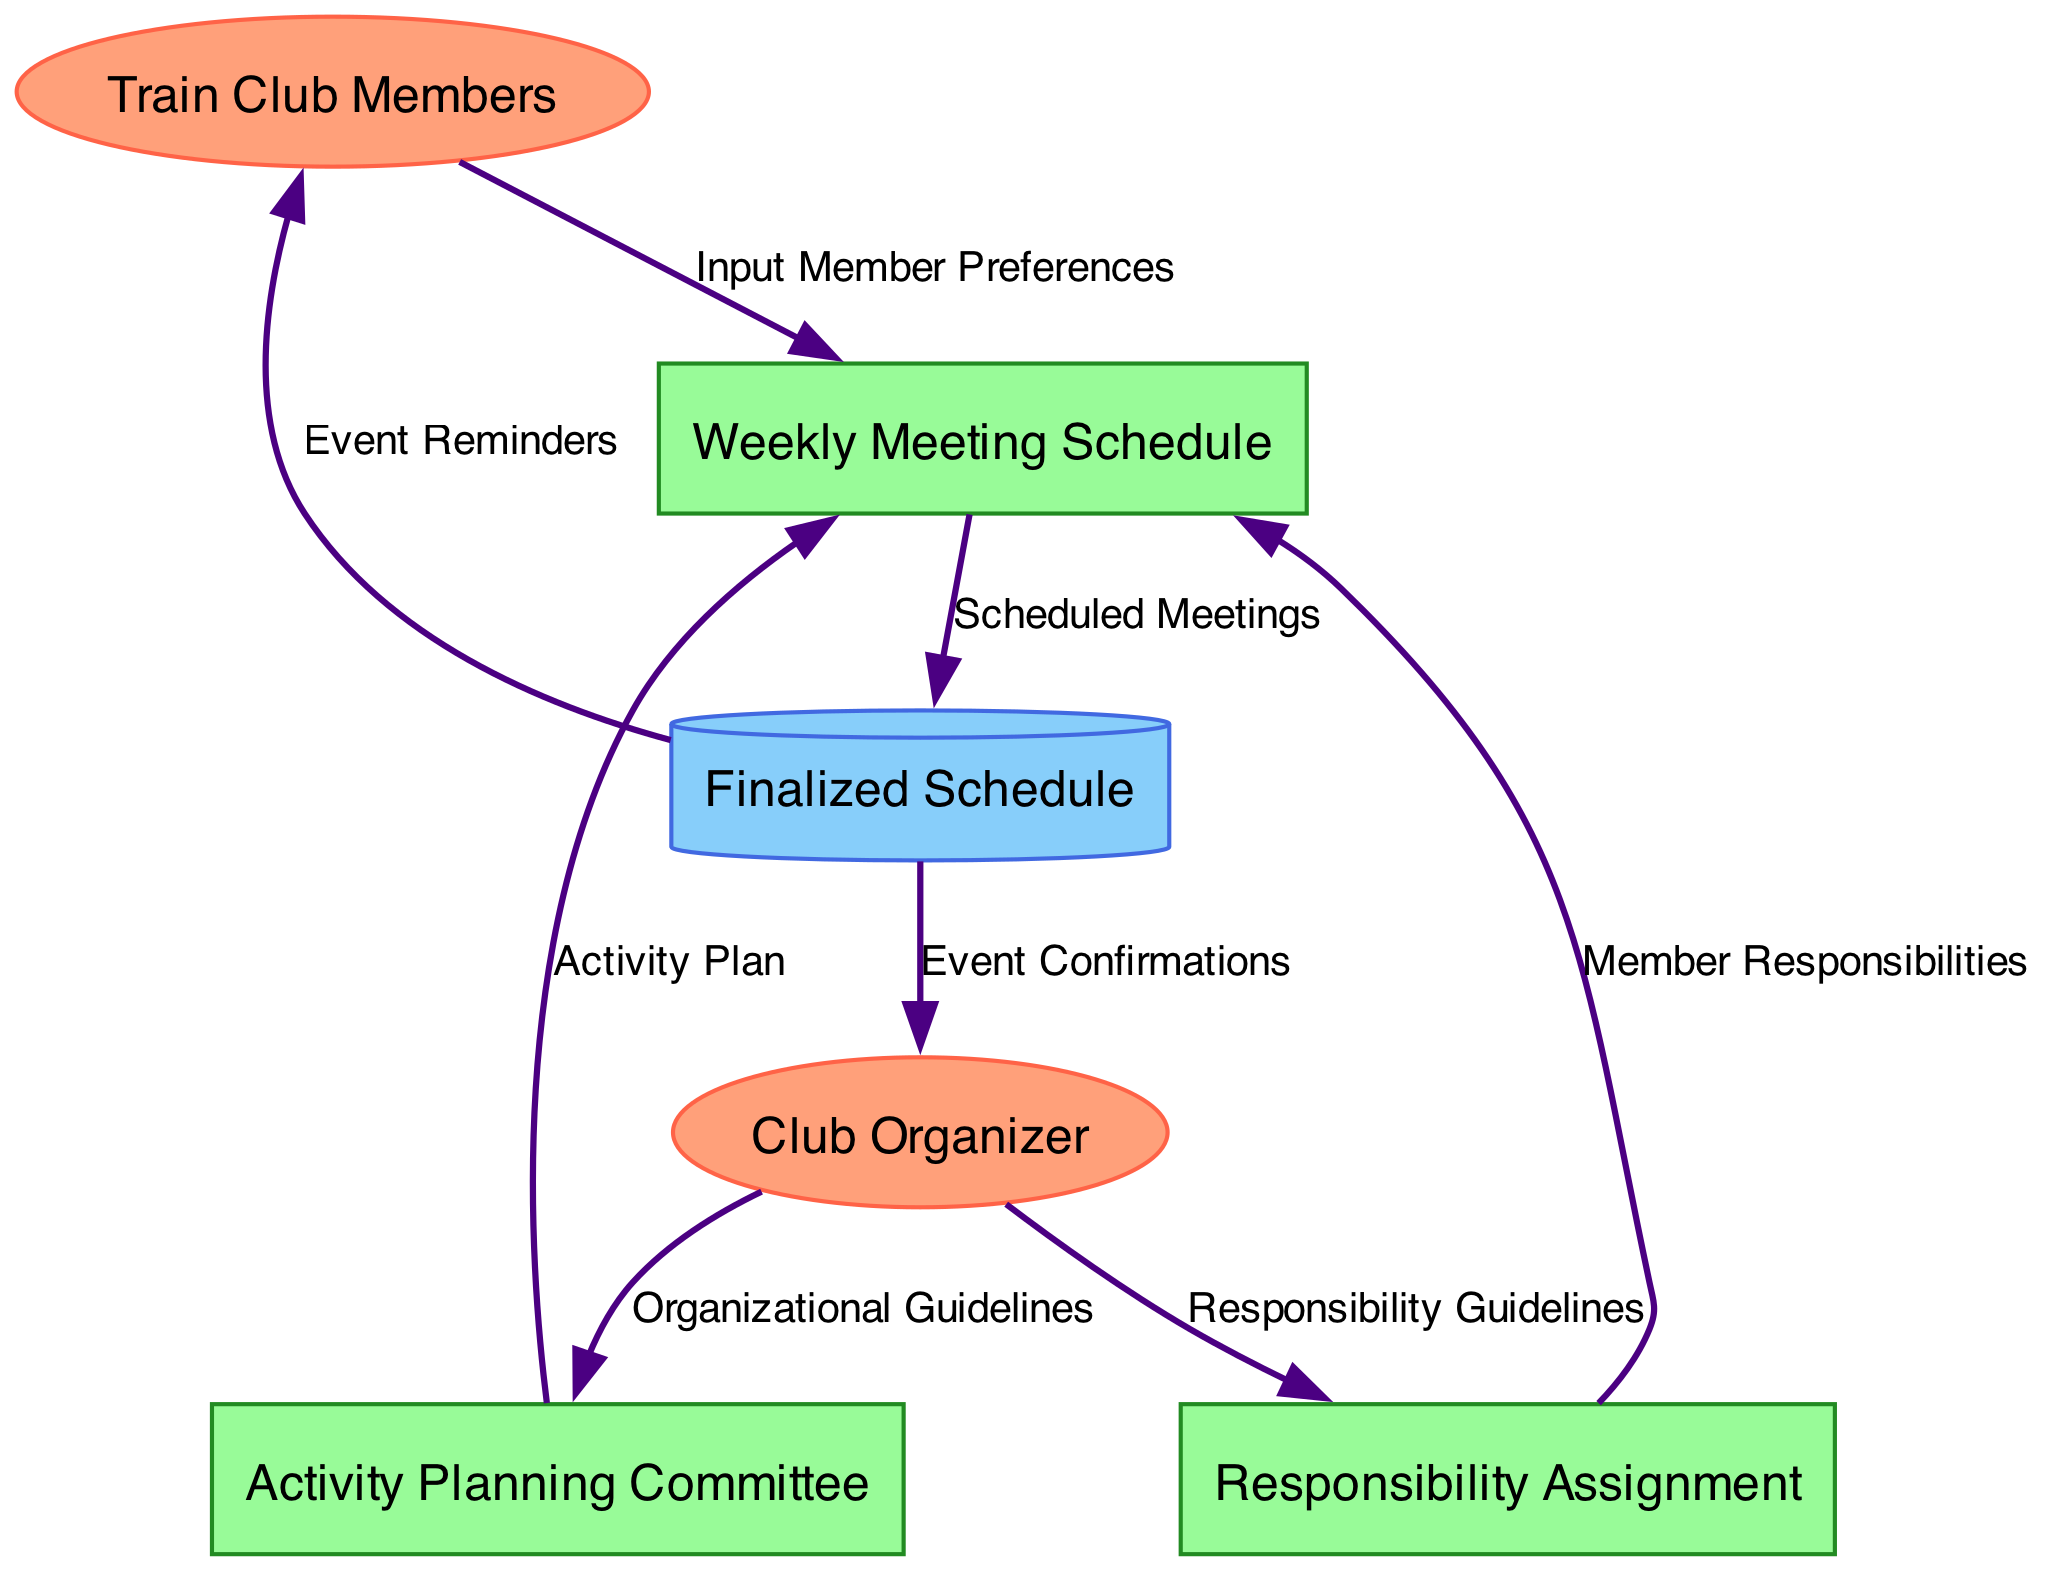What are the inputs for the Weekly Meeting Schedule process? The inputs to the Weekly Meeting Schedule process are gathered from Train Club Members, Activity Plan, and Member Responsibilities nodes. Each of these contribute specific information required to create the schedule.
Answer: Train Club Members, Activity Plan, Member Responsibilities How many processes are present in the diagram? The diagram features three processes: Weekly Meeting Schedule, Activity Planning Committee, and Responsibility Assignment. Each process has distinct roles in organizing the club's daily schedule.
Answer: Three What output does the Responsibility Assignment process generate? The Responsibility Assignment process produces "Member Responsibilities" as its output, detailing what each member is responsible for regarding activities and meetings.
Answer: Member Responsibilities What flows from the Finalized Schedule to the Train Club Members? The output that flows from the Finalized Schedule to the Train Club Members is "Event Reminders," which inform them of scheduled activities and meetings.
Answer: Event Reminders Which external entity is responsible for the guidelines sent to the Activity Planning Committee? The external entity providing the guidelines to the Activity Planning Committee is the Club Organizer, who is responsible for setting the organizational parameters for planning.
Answer: Club Organizer How do the Club Organizer and Train Club Members interact in this diagram? The Club Organizer interacts with Train Club Members through both the Activity Planning Committee and the Responsibility Assignment processes, facilitating activity planning and responsibility assignment.
Answer: Two processes What is the final outcome of the Weekly Meeting Schedule process? The final outcome of the Weekly Meeting Schedule process is the "Finalized Schedule," which contains all the scheduled meetings based on member inputs and assigned responsibilities.
Answer: Finalized Schedule What is the role of the Activity Planning Committee in the diagram? The role of the Activity Planning Committee is to receive input from the Club Organizer and Train Club Members to create the "Activity Plan" for future meetings and events.
Answer: Activity Plan What data flows from the Weekly Meeting Schedule to the Finalized Schedule? The data that flows from the Weekly Meeting Schedule to the Finalized Schedule is "Scheduled Meetings," which outlines the timing and details of club events.
Answer: Scheduled Meetings 